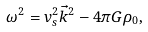<formula> <loc_0><loc_0><loc_500><loc_500>\omega ^ { 2 } = v _ { s } ^ { 2 } \vec { k } ^ { 2 } - 4 \pi G \rho _ { 0 } ,</formula> 